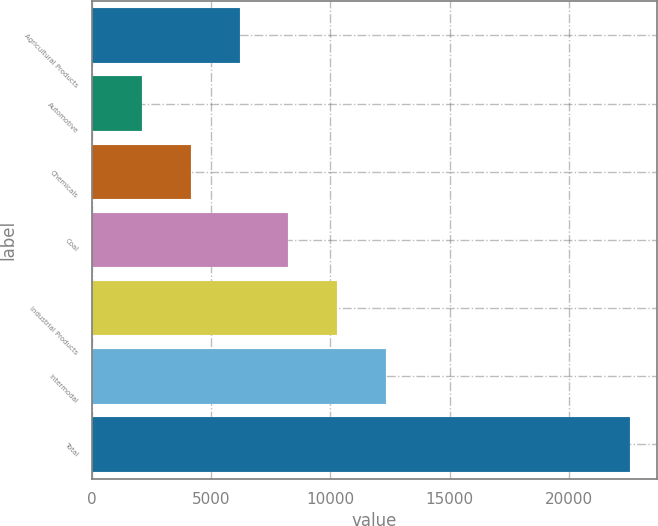Convert chart. <chart><loc_0><loc_0><loc_500><loc_500><bar_chart><fcel>Agricultural Products<fcel>Automotive<fcel>Chemicals<fcel>Coal<fcel>Industrial Products<fcel>Intermodal<fcel>Total<nl><fcel>6194.4<fcel>2103<fcel>4148.7<fcel>8240.1<fcel>10285.8<fcel>12331.5<fcel>22560<nl></chart> 